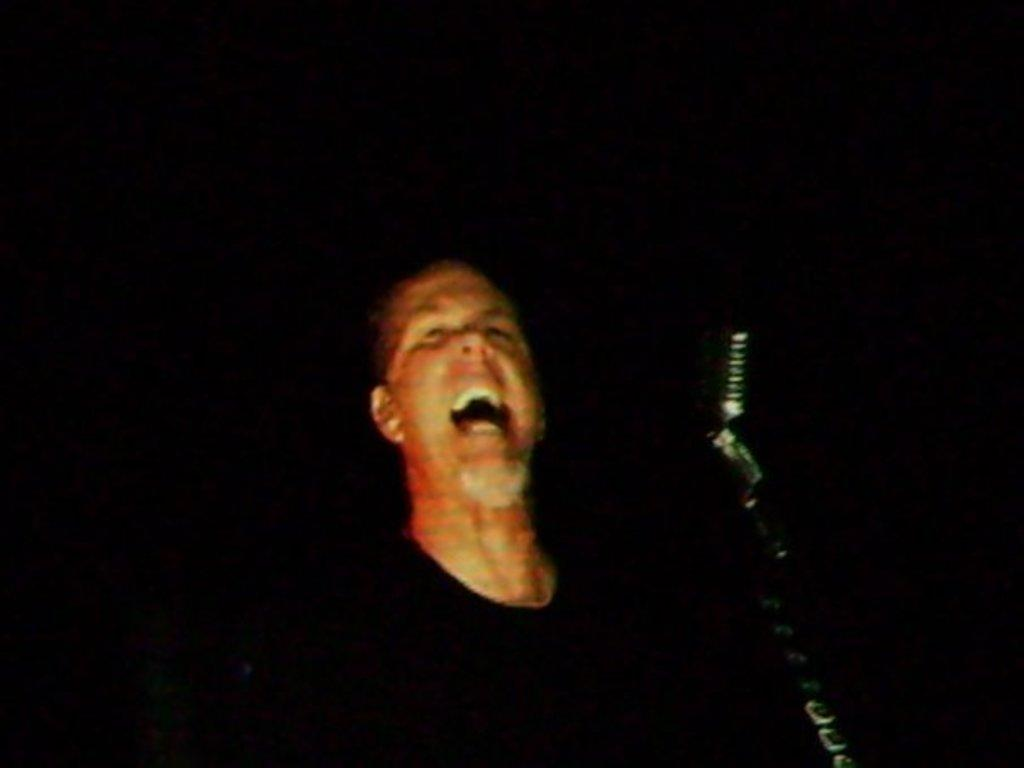Who is the main subject in the image? There is a person in the center of the image. What is the person doing in the image? The person is shouting. What object is in front of the person? There is a microphone in front of the person. What color is the background of the image? The background of the image is black. How many ducks can be seen in the person's eye in the image? There are no ducks visible in the person's eye or anywhere else in the image. 